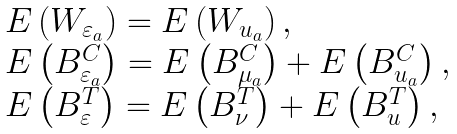Convert formula to latex. <formula><loc_0><loc_0><loc_500><loc_500>\begin{array} { l } E \left ( W _ { \varepsilon _ { a } } \right ) = E \left ( W _ { u _ { a } } \right ) , \\ E \left ( B _ { \varepsilon _ { a } } ^ { C } \right ) = E \left ( B _ { \mu _ { a } } ^ { C } \right ) + E \left ( B _ { u _ { a } } ^ { C } \right ) , \\ E \left ( B _ { \varepsilon } ^ { T } \right ) = E \left ( B _ { \nu } ^ { T } \right ) + E \left ( B _ { u } ^ { T } \right ) , \end{array}</formula> 